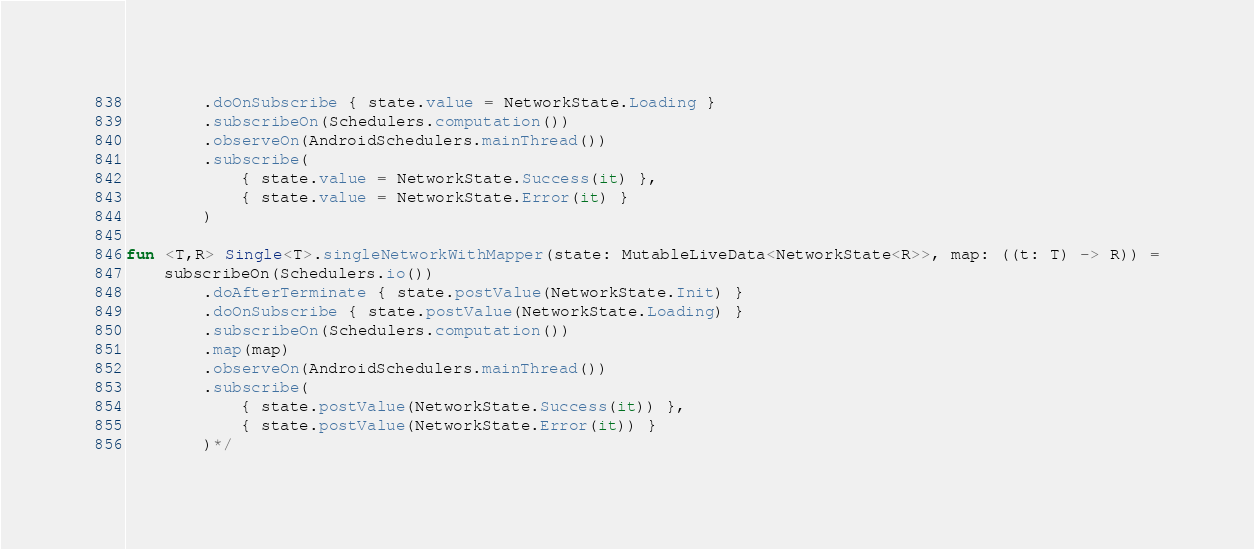Convert code to text. <code><loc_0><loc_0><loc_500><loc_500><_Kotlin_>        .doOnSubscribe { state.value = NetworkState.Loading }
        .subscribeOn(Schedulers.computation())
        .observeOn(AndroidSchedulers.mainThread())
        .subscribe(
            { state.value = NetworkState.Success(it) },
            { state.value = NetworkState.Error(it) }
        )

fun <T,R> Single<T>.singleNetworkWithMapper(state: MutableLiveData<NetworkState<R>>, map: ((t: T) -> R)) =
    subscribeOn(Schedulers.io())
        .doAfterTerminate { state.postValue(NetworkState.Init) }
        .doOnSubscribe { state.postValue(NetworkState.Loading) }
        .subscribeOn(Schedulers.computation())
        .map(map)
        .observeOn(AndroidSchedulers.mainThread())
        .subscribe(
            { state.postValue(NetworkState.Success(it)) },
            { state.postValue(NetworkState.Error(it)) }
        )*/
</code> 